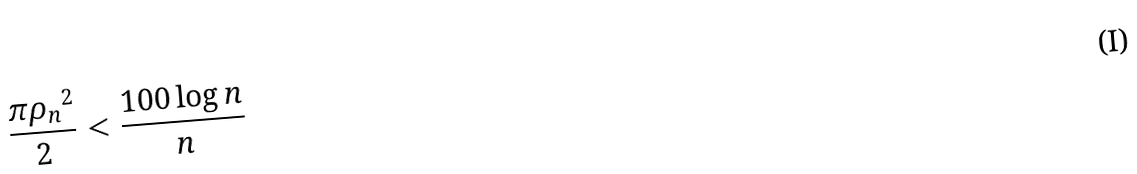<formula> <loc_0><loc_0><loc_500><loc_500>\frac { \pi { \rho _ { n } } ^ { 2 } } { 2 } & < \frac { 1 0 0 \log n } { n }</formula> 